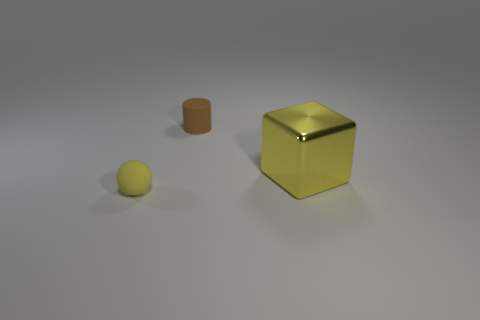What time of day does this setting suggest? The setting doesn't provide definitive clues about the time of day since it looks like a controlled indoor environment with artificial lighting rather than natural sunlight. The shadows are soft and diffuse, which typically would occur under even, studio-like lighting conditions. 